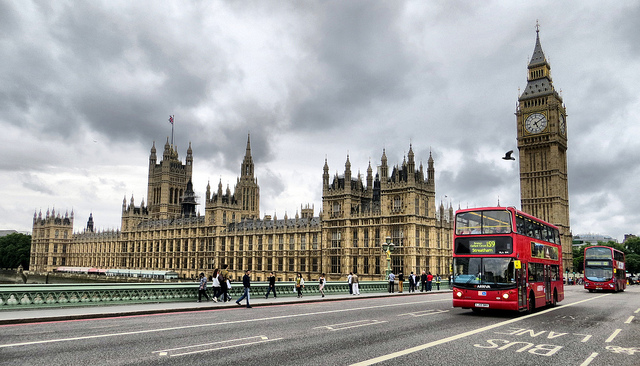Identify and read out the text in this image. BUS LANE 